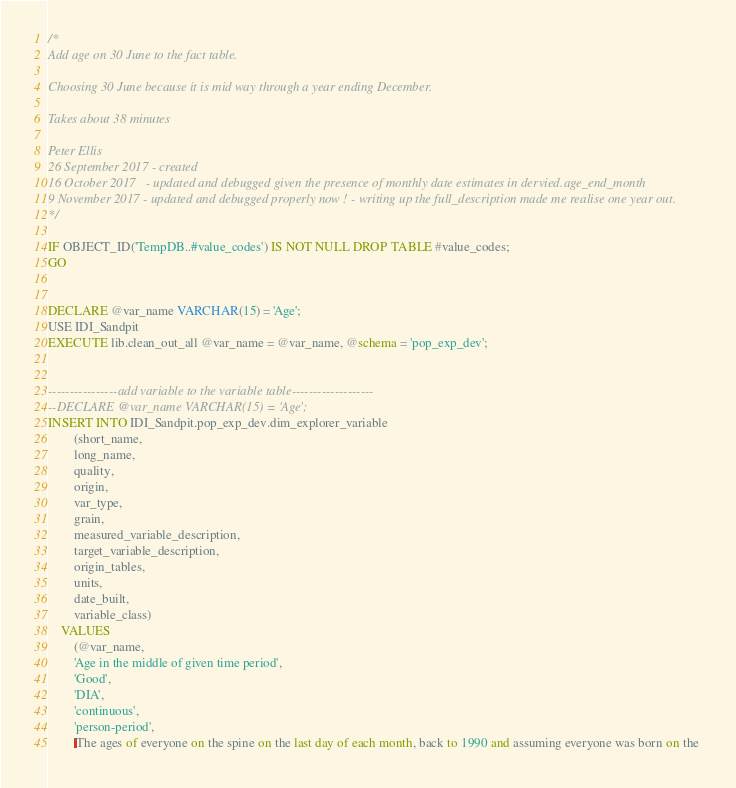<code> <loc_0><loc_0><loc_500><loc_500><_SQL_>/*
Add age on 30 June to the fact table.
 
Choosing 30 June because it is mid way through a year ending December.

Takes about 38 minutes

Peter Ellis 
26 September 2017 - created
16 October 2017   - updated and debugged given the presence of monthly date estimates in dervied.age_end_month
9 November 2017 - updated and debugged properly now ! - writing up the full_description made me realise one year out.
*/

IF OBJECT_ID('TempDB..#value_codes') IS NOT NULL DROP TABLE #value_codes;
GO 


DECLARE @var_name VARCHAR(15) = 'Age';
USE IDI_Sandpit
EXECUTE lib.clean_out_all @var_name = @var_name, @schema = 'pop_exp_dev';


----------------add variable to the variable table-------------------
--DECLARE @var_name VARCHAR(15) = 'Age';
INSERT INTO IDI_Sandpit.pop_exp_dev.dim_explorer_variable
		(short_name, 
		long_name,
		quality,
		origin,
		var_type,
		grain,
		measured_variable_description,
		target_variable_description,
		origin_tables,
		units,
		date_built,
		variable_class) 
	VALUES   
		(@var_name,
		'Age in the middle of given time period',
		'Good',
		'DIA',
		'continuous',
		'person-period',
		'The ages of everyone on the spine on the last day of each month, back to 1990 and assuming everyone was born on the </code> 